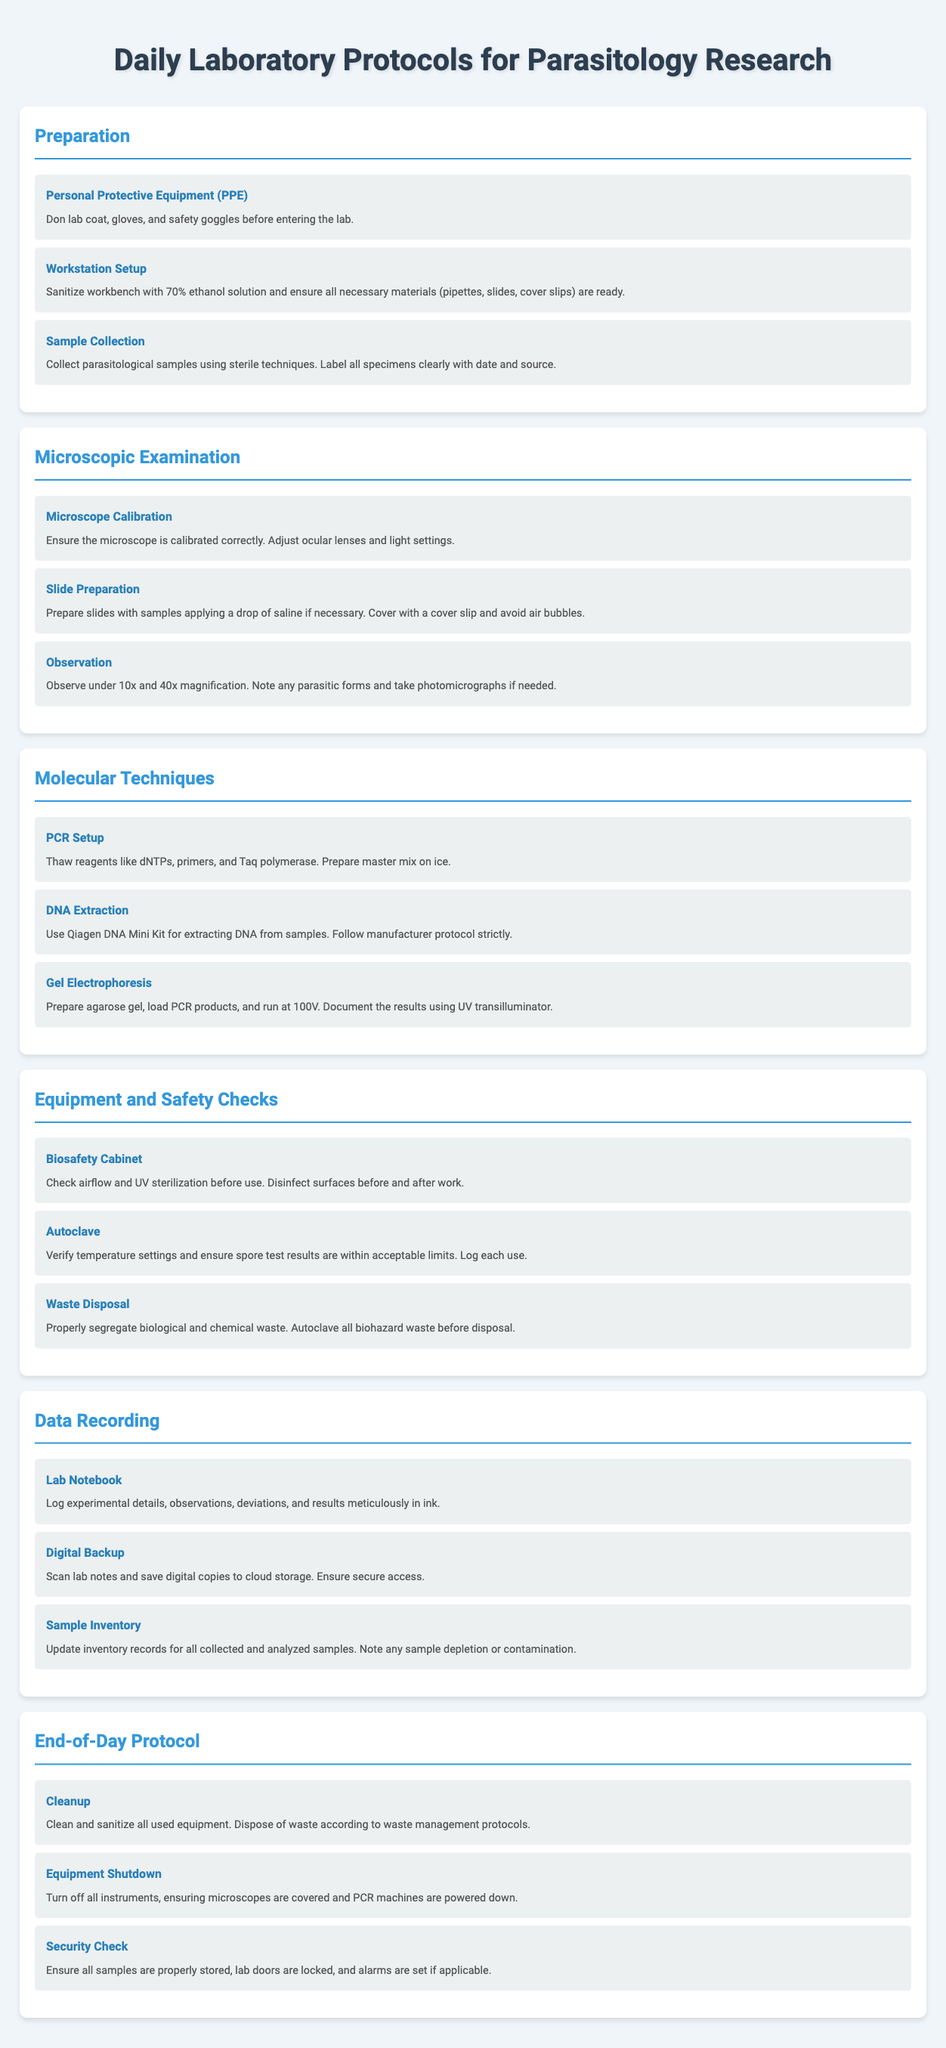what PPE should be worn before entering the lab? The document states that one should don a lab coat, gloves, and safety goggles before entering the lab.
Answer: lab coat, gloves, safety goggles what materials are needed for workstation setup? The workstation setup requires sanitization with 70% ethanol solution and necessary materials like pipettes, slides, and cover slips.
Answer: pipettes, slides, cover slips how should the microscope be prepared for use? The document instructs to ensure the microscope is calibrated correctly by adjusting ocular lenses and light settings.
Answer: calibrated correctly what is the voltage used when running gel electrophoresis? According to the document, the agrose gel during gel electrophoresis should be run at 100V.
Answer: 100V how often should the autoclave be logged? The document does not specify a number, but it states that each use of the autoclave should be logged.
Answer: each use which safety equipment needs to be checked in the laboratory? The document mentions checking airflow and UV sterilization in the biosafety cabinet as part of the safety equipment checks.
Answer: biosafety cabinet what type of waste should be autoclaved before disposal? The document specifies that all biohazard waste should be autoclaved before disposal.
Answer: biohazard waste what should be recorded in the lab notebook? The lab notebook should log experimental details, observations, deviations, and results meticulously in ink.
Answer: experimental details what should be done after using all equipment for the day? The end-of-day protocol includes cleaning and sanitizing all used equipment.
Answer: clean and sanitize 